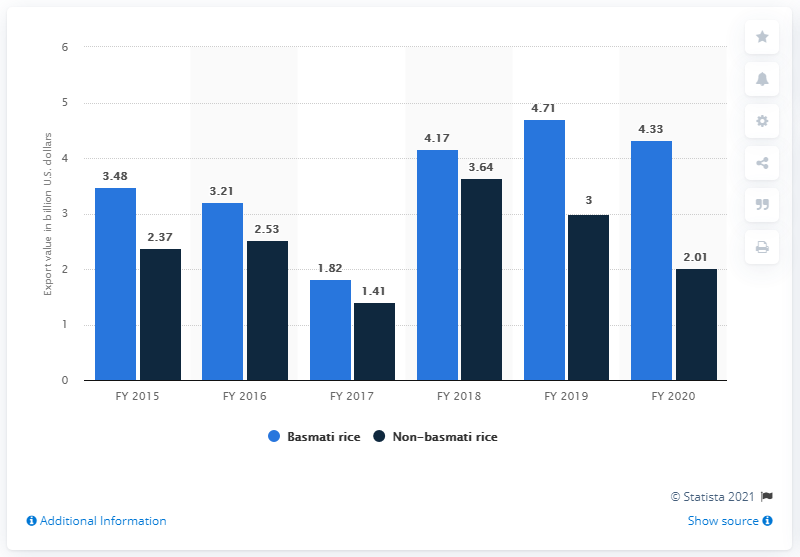Identify some key points in this picture. The export value of other rice varieties during fiscal year 2020 was 4,330.. In fiscal year 2020, the value of Basmati rice in US dollars was approximately 4.33. 